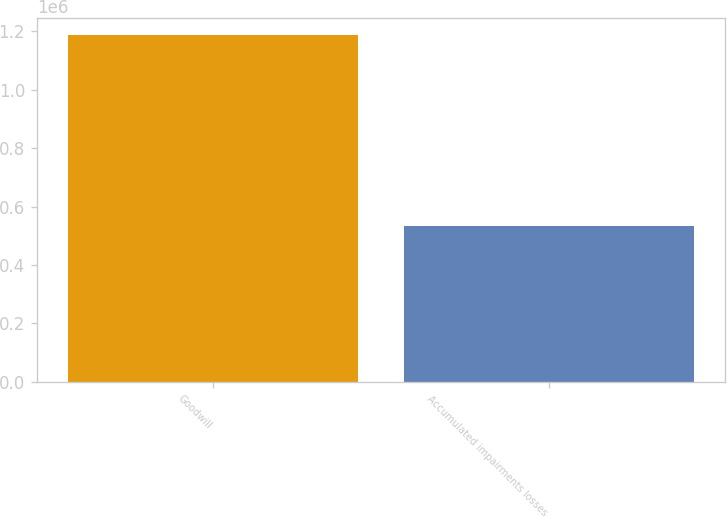<chart> <loc_0><loc_0><loc_500><loc_500><bar_chart><fcel>Goodwill<fcel>Accumulated impairments losses<nl><fcel>1.18691e+06<fcel>531930<nl></chart> 